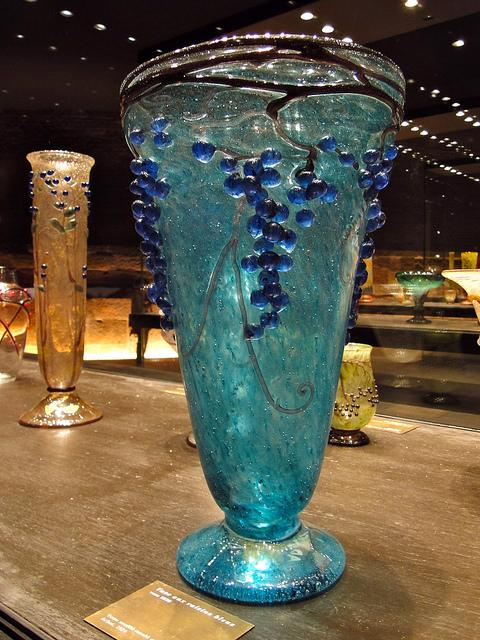What venue is this likely to be? museum 